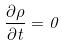<formula> <loc_0><loc_0><loc_500><loc_500>\frac { \partial \rho } { \partial t } = 0</formula> 